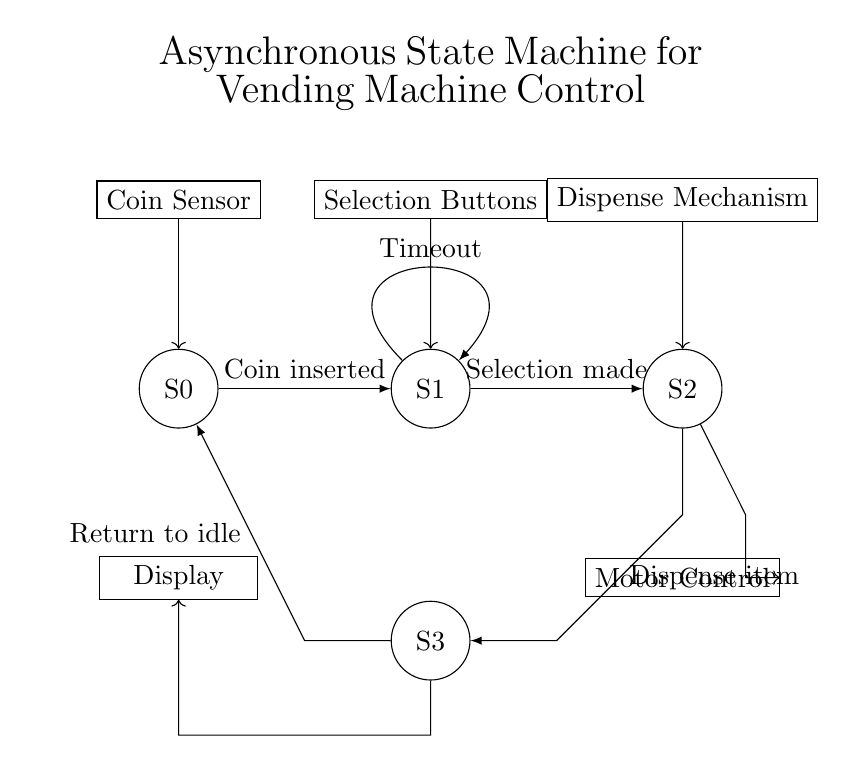What is the initial state of the vending machine? The initial state of the vending machine is S0, where it is idle and waiting for a coin to be inserted. This is indicated by the position of the state circles in the diagram.
Answer: S0 How many total states are there in this state machine? The state machine consists of four identified states: S0, S1, S2, and S3. The diagrams show four circles representing these states.
Answer: Four What action causes the transition from S0 to S1? The transition from S0 to S1 occurs when a coin is inserted, as indicated by the labeled arrow connecting the two states.
Answer: Coin inserted What is the purpose of the timeout transition in S1? The timeout transition in S1 is used to handle scenarios where no selection is made within a set time period, keeping the system in a safe state. This is represented by a self-loop on S1.
Answer: Handle no selection Which component is responsible for dispensing items? The dispensing mechanism is responsible for dispensing items, as indicated in the circuit diagram next to state S2.
Answer: Dispense mechanism In which state does the machine wait for the user's selection? The machine waits for the user's selection in state S1, where the selection buttons are activated after the coin is inserted.
Answer: S1 What happens when the machine is in state S3? When in state S3, the machine returns to the idle state (S0) after completing the item dispensing operation. This is represented by the transition back to S0.
Answer: Return to idle 